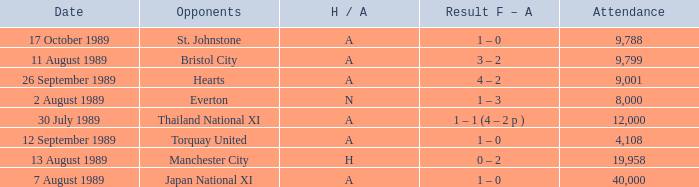Could you help me parse every detail presented in this table? {'header': ['Date', 'Opponents', 'H / A', 'Result F – A', 'Attendance'], 'rows': [['17 October 1989', 'St. Johnstone', 'A', '1 – 0', '9,788'], ['11 August 1989', 'Bristol City', 'A', '3 – 2', '9,799'], ['26 September 1989', 'Hearts', 'A', '4 – 2', '9,001'], ['2 August 1989', 'Everton', 'N', '1 – 3', '8,000'], ['30 July 1989', 'Thailand National XI', 'A', '1 – 1 (4 – 2 p )', '12,000'], ['12 September 1989', 'Torquay United', 'A', '1 – 0', '4,108'], ['13 August 1989', 'Manchester City', 'H', '0 – 2', '19,958'], ['7 August 1989', 'Japan National XI', 'A', '1 – 0', '40,000']]} How many people attended the match when Manchester United played against the Hearts? 9001.0. 